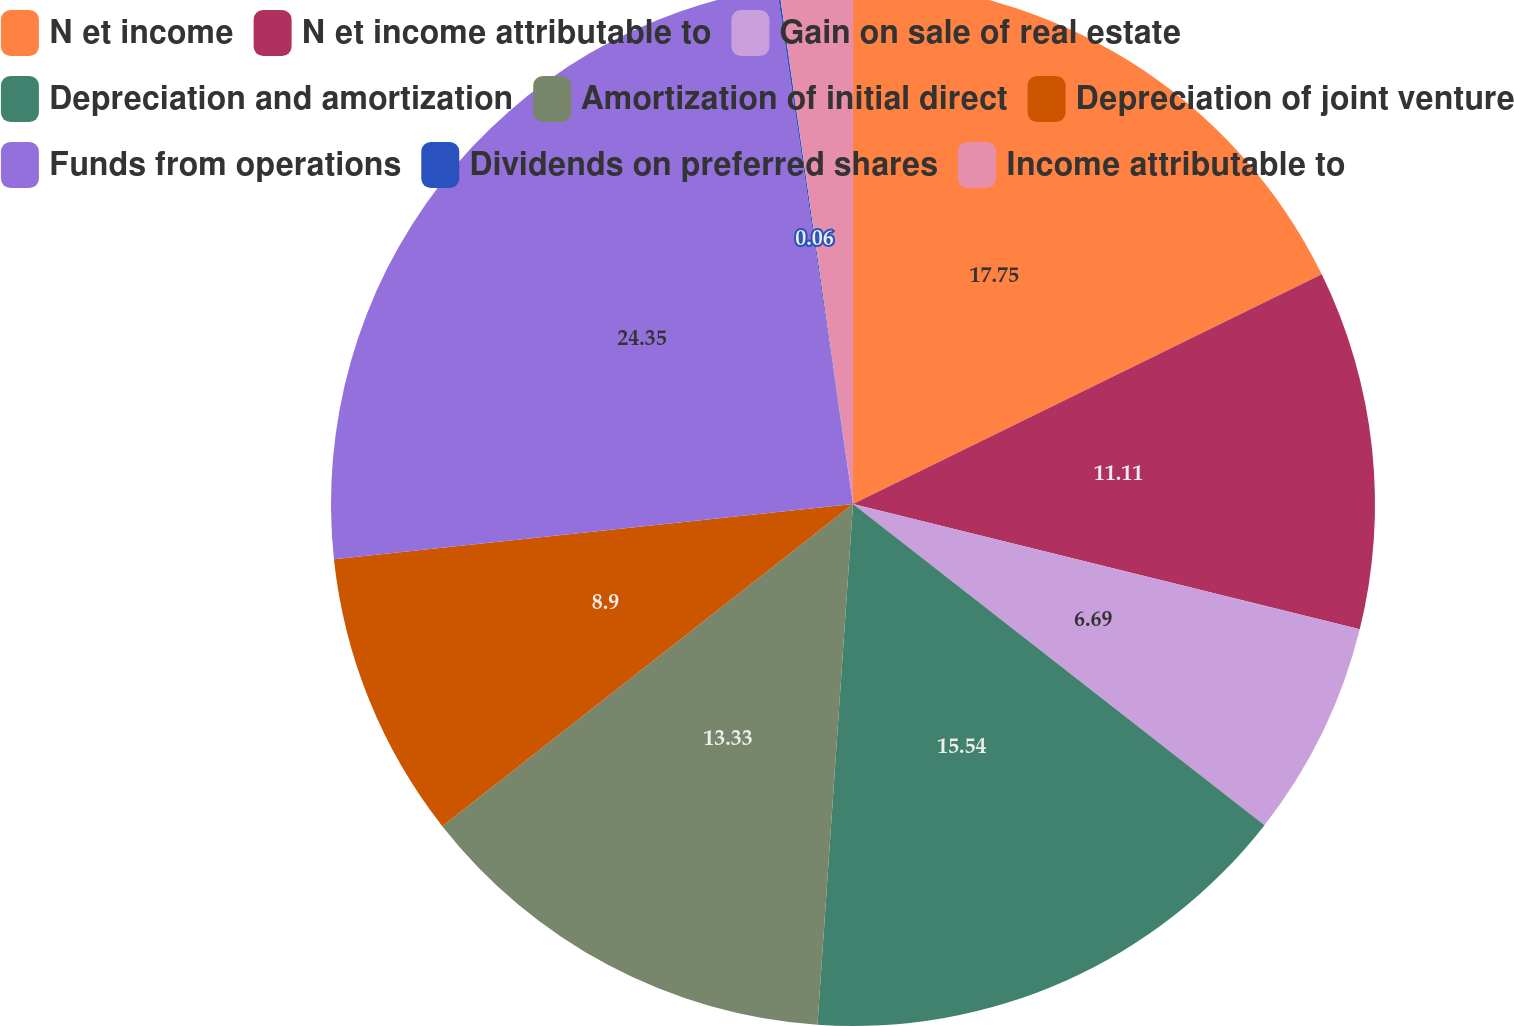Convert chart to OTSL. <chart><loc_0><loc_0><loc_500><loc_500><pie_chart><fcel>N et income<fcel>N et income attributable to<fcel>Gain on sale of real estate<fcel>Depreciation and amortization<fcel>Amortization of initial direct<fcel>Depreciation of joint venture<fcel>Funds from operations<fcel>Dividends on preferred shares<fcel>Income attributable to<nl><fcel>17.75%<fcel>11.11%<fcel>6.69%<fcel>15.54%<fcel>13.33%<fcel>8.9%<fcel>24.36%<fcel>0.06%<fcel>2.27%<nl></chart> 